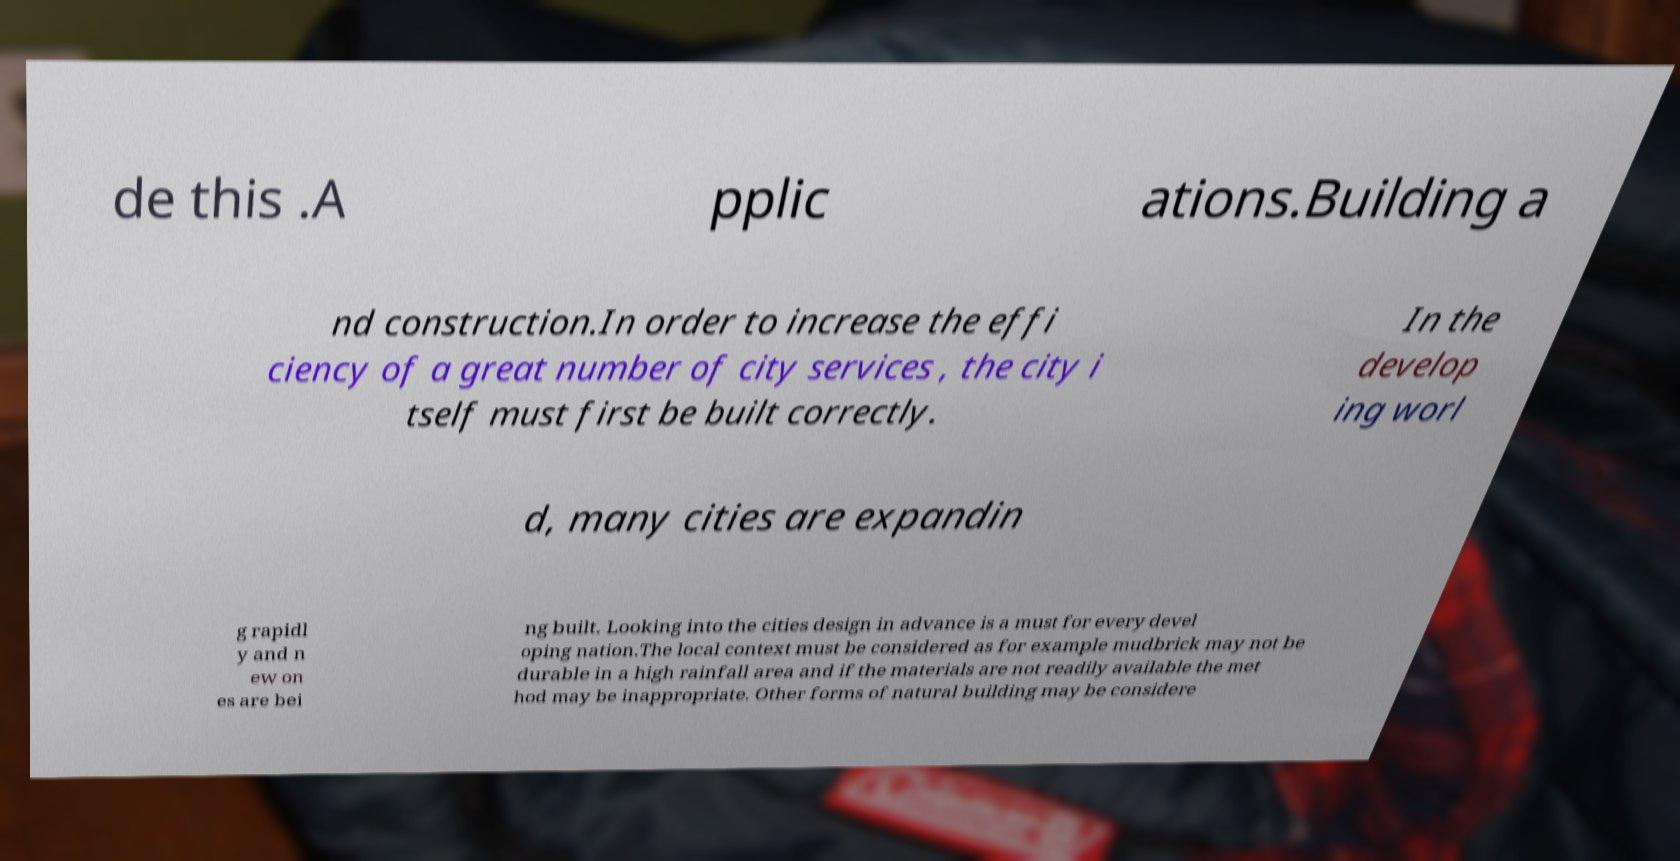Please read and relay the text visible in this image. What does it say? de this .A pplic ations.Building a nd construction.In order to increase the effi ciency of a great number of city services , the city i tself must first be built correctly. In the develop ing worl d, many cities are expandin g rapidl y and n ew on es are bei ng built. Looking into the cities design in advance is a must for every devel oping nation.The local context must be considered as for example mudbrick may not be durable in a high rainfall area and if the materials are not readily available the met hod may be inappropriate. Other forms of natural building may be considere 